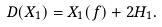Convert formula to latex. <formula><loc_0><loc_0><loc_500><loc_500>D ( X _ { 1 } ) = X _ { 1 } ( f ) + 2 H _ { 1 } .</formula> 